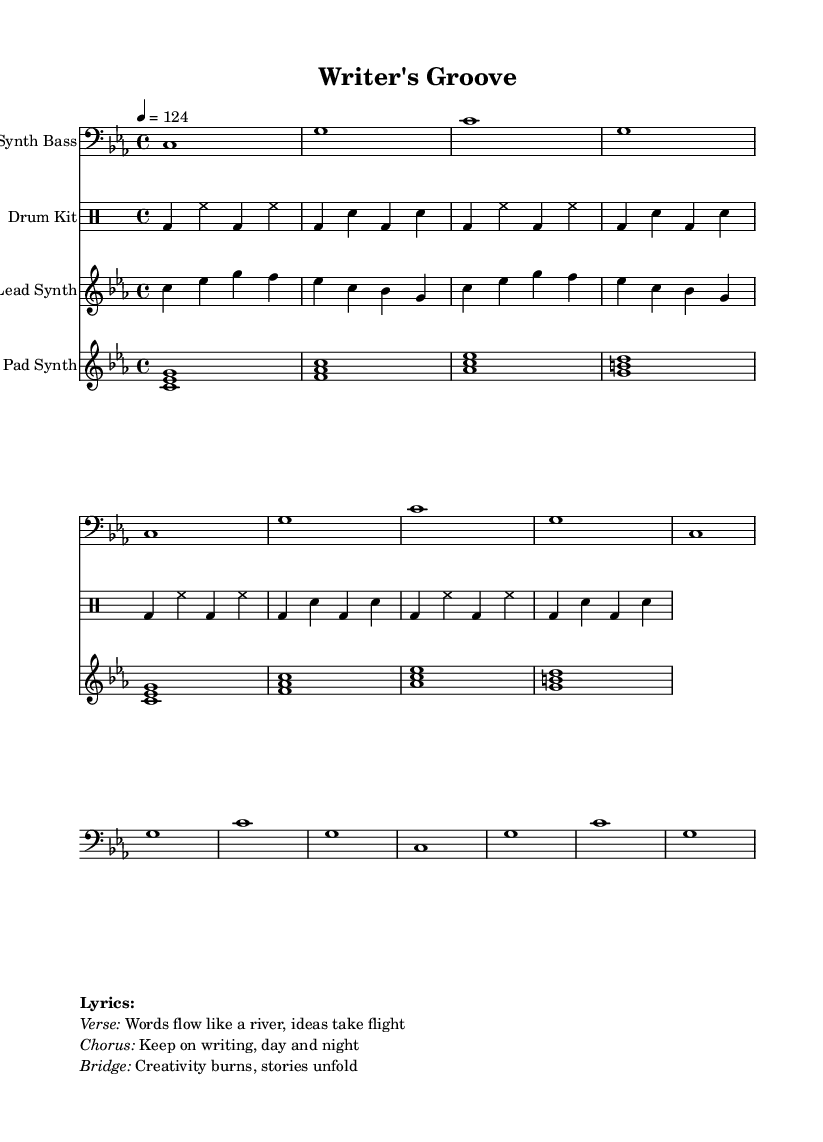What is the key signature of this music? The key signature indicated at the beginning of the score is C minor, which typically contains three flats in its key signature.
Answer: C minor What is the time signature of this music? The time signature shown in the score is 4/4, which means there are four beats per measure and the quarter note gets one beat.
Answer: 4/4 What is the tempo marking of this piece? The tempo marking at the start indicates a speed of 124 beats per minute, set as a quarter note.
Answer: 124 How many measures does the lead synth part have in total? The lead synth section is repeated two times, with each repeat being four measures long, resulting in a total of eight measures.
Answer: 8 What musical elements are present in the drum kit part? The drum kit part consists of a kick drum (bd), snare drum (sn), and hi-hat (hh), as indicated by the different symbols used.
Answer: Kick, snare, hi-hat What theme is reflected in the lyrics of the chorus? The lyrics of the chorus emphasize perseverance in writing, showcasing the commitment to writing continuously day and night.
Answer: Perseverance How does the structure of the song support the dance genre? The repetitive and rhythmic nature of the synth bass and drum kit creates a steady groove that is essential for dance music, allowing for movement and interaction.
Answer: Steady groove 